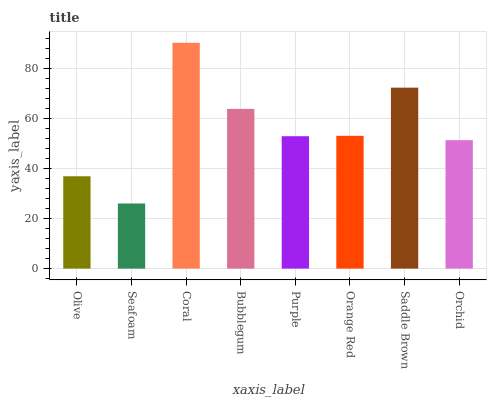Is Seafoam the minimum?
Answer yes or no. Yes. Is Coral the maximum?
Answer yes or no. Yes. Is Coral the minimum?
Answer yes or no. No. Is Seafoam the maximum?
Answer yes or no. No. Is Coral greater than Seafoam?
Answer yes or no. Yes. Is Seafoam less than Coral?
Answer yes or no. Yes. Is Seafoam greater than Coral?
Answer yes or no. No. Is Coral less than Seafoam?
Answer yes or no. No. Is Orange Red the high median?
Answer yes or no. Yes. Is Purple the low median?
Answer yes or no. Yes. Is Olive the high median?
Answer yes or no. No. Is Seafoam the low median?
Answer yes or no. No. 